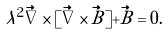<formula> <loc_0><loc_0><loc_500><loc_500>\lambda ^ { 2 } \vec { \nabla } \times [ \vec { \nabla } \times \vec { B } ] + \vec { B } = 0 .</formula> 